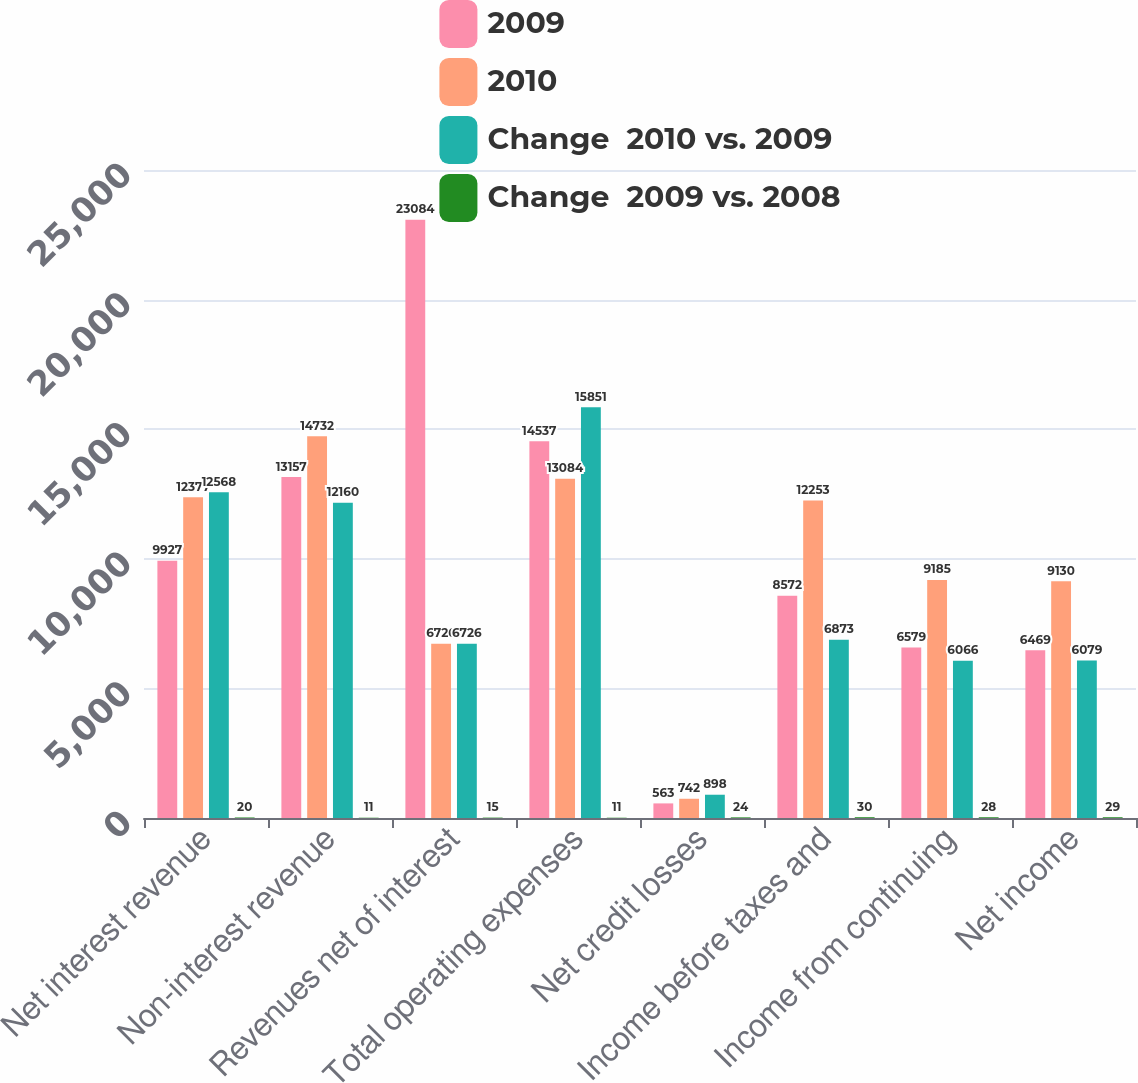Convert chart to OTSL. <chart><loc_0><loc_0><loc_500><loc_500><stacked_bar_chart><ecel><fcel>Net interest revenue<fcel>Non-interest revenue<fcel>Revenues net of interest<fcel>Total operating expenses<fcel>Net credit losses<fcel>Income before taxes and<fcel>Income from continuing<fcel>Net income<nl><fcel>2009<fcel>9927<fcel>13157<fcel>23084<fcel>14537<fcel>563<fcel>8572<fcel>6579<fcel>6469<nl><fcel>2010<fcel>12377<fcel>14732<fcel>6726<fcel>13084<fcel>742<fcel>12253<fcel>9185<fcel>9130<nl><fcel>Change  2010 vs. 2009<fcel>12568<fcel>12160<fcel>6726<fcel>15851<fcel>898<fcel>6873<fcel>6066<fcel>6079<nl><fcel>Change  2009 vs. 2008<fcel>20<fcel>11<fcel>15<fcel>11<fcel>24<fcel>30<fcel>28<fcel>29<nl></chart> 